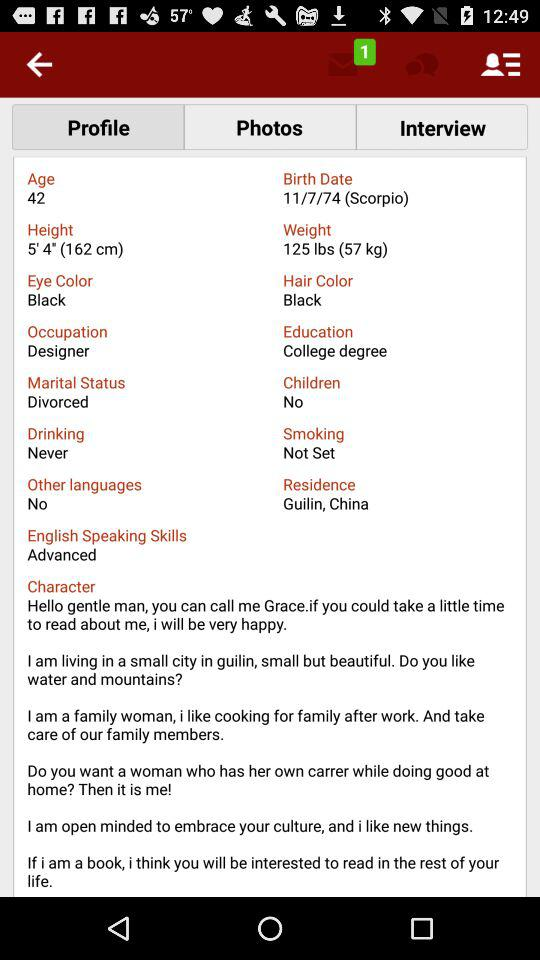Is the smoking status set? The smoking status is not set. 